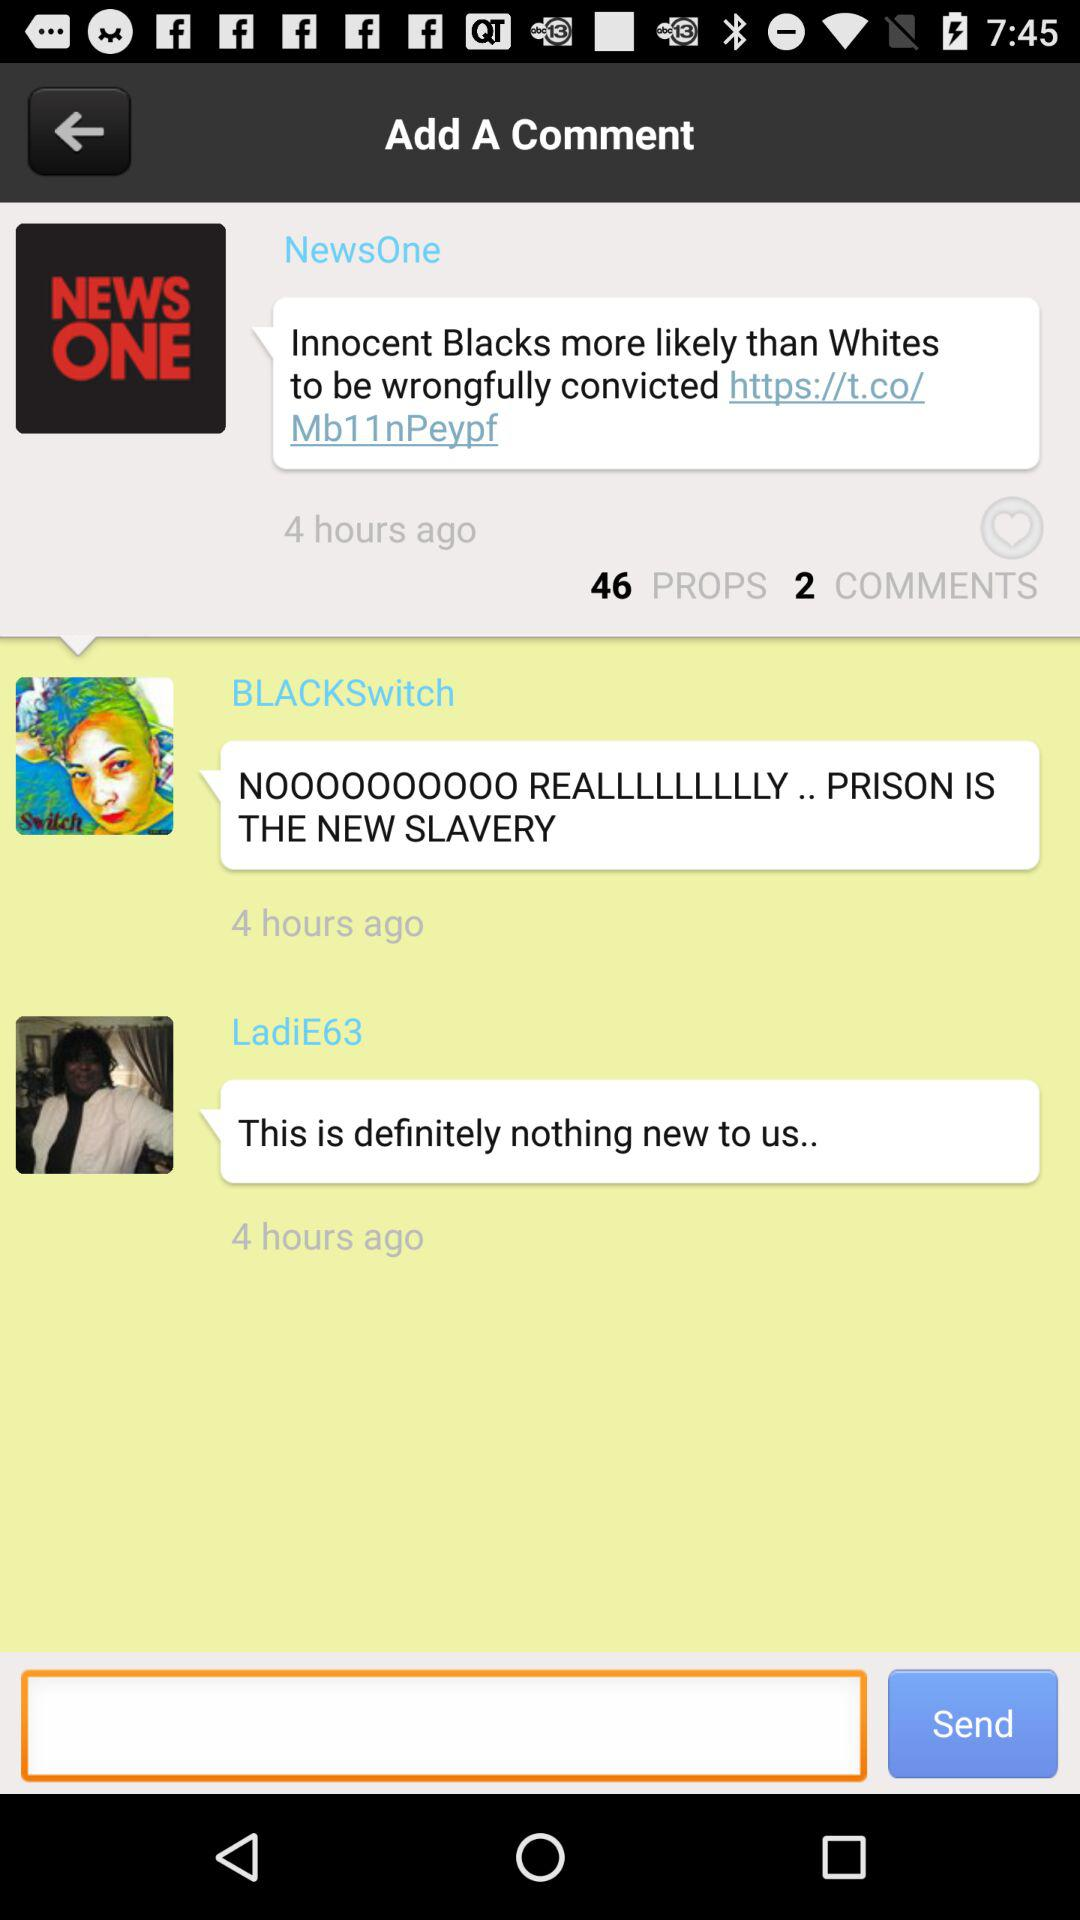What is the number of props? The number of props is 46. 